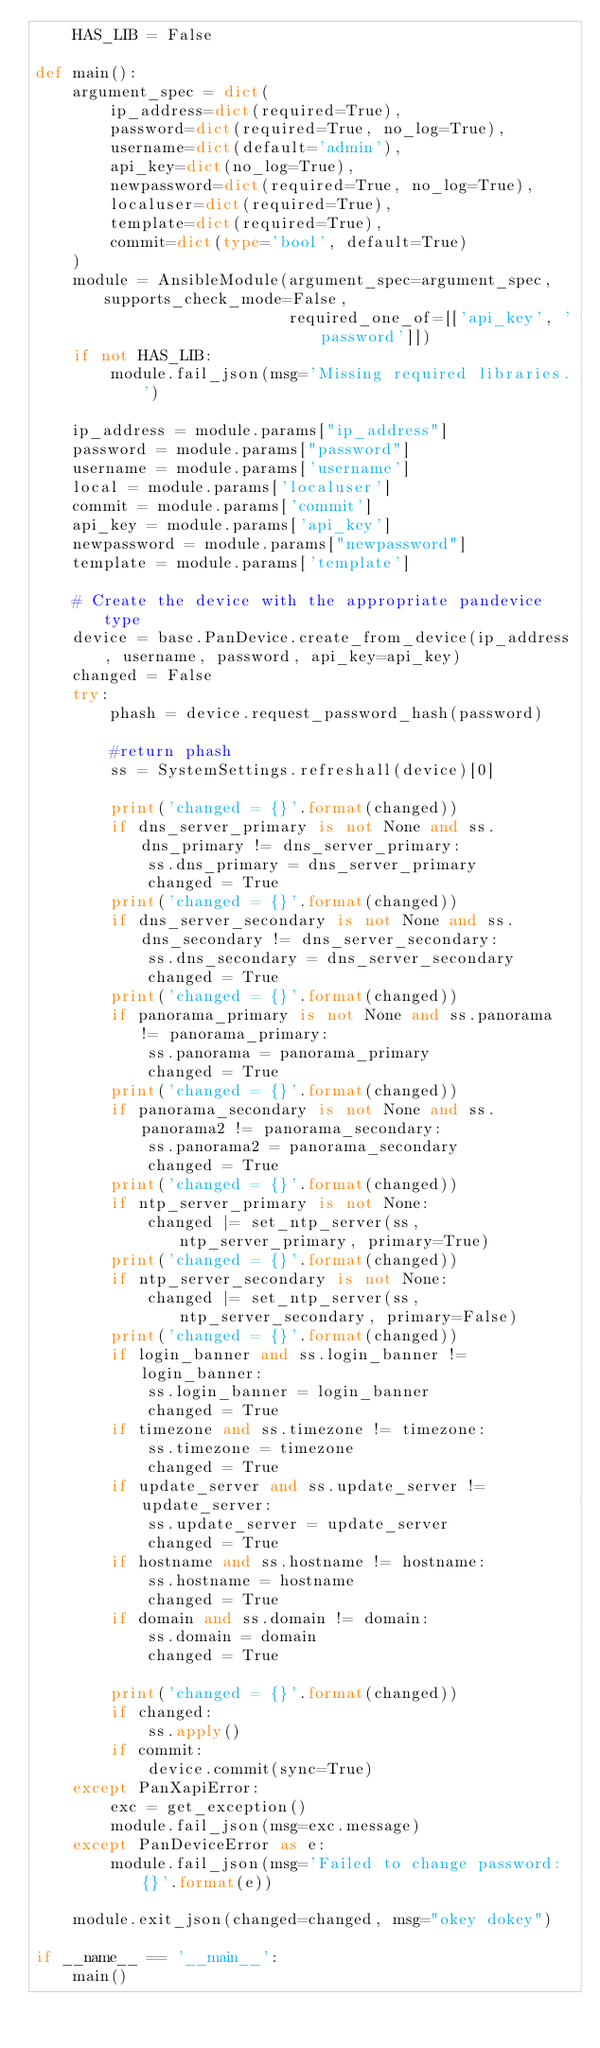<code> <loc_0><loc_0><loc_500><loc_500><_Python_>    HAS_LIB = False

def main():
    argument_spec = dict(
        ip_address=dict(required=True),
        password=dict(required=True, no_log=True),
        username=dict(default='admin'),
        api_key=dict(no_log=True),
        newpassword=dict(required=True, no_log=True),
        localuser=dict(required=True),
        template=dict(required=True),
        commit=dict(type='bool', default=True)
    )
    module = AnsibleModule(argument_spec=argument_spec, supports_check_mode=False,
                           required_one_of=[['api_key', 'password']])
    if not HAS_LIB:
        module.fail_json(msg='Missing required libraries.')

    ip_address = module.params["ip_address"]
    password = module.params["password"]
    username = module.params['username']
    local = module.params['localuser']
    commit = module.params['commit']
    api_key = module.params['api_key']
    newpassword = module.params["newpassword"]    
    template = module.params['template']

    # Create the device with the appropriate pandevice type
    device = base.PanDevice.create_from_device(ip_address, username, password, api_key=api_key)
    changed = False
    try:
        phash = device.request_password_hash(password)

        #return phash        
        ss = SystemSettings.refreshall(device)[0]

        print('changed = {}'.format(changed))
        if dns_server_primary is not None and ss.dns_primary != dns_server_primary:
            ss.dns_primary = dns_server_primary
            changed = True
        print('changed = {}'.format(changed))
        if dns_server_secondary is not None and ss.dns_secondary != dns_server_secondary:
            ss.dns_secondary = dns_server_secondary
            changed = True
        print('changed = {}'.format(changed))
        if panorama_primary is not None and ss.panorama != panorama_primary:
            ss.panorama = panorama_primary
            changed = True
        print('changed = {}'.format(changed))
        if panorama_secondary is not None and ss.panorama2 != panorama_secondary:
            ss.panorama2 = panorama_secondary
            changed = True
        print('changed = {}'.format(changed))
        if ntp_server_primary is not None:
            changed |= set_ntp_server(ss, ntp_server_primary, primary=True)
        print('changed = {}'.format(changed))
        if ntp_server_secondary is not None:
            changed |= set_ntp_server(ss, ntp_server_secondary, primary=False)
        print('changed = {}'.format(changed))
        if login_banner and ss.login_banner != login_banner:
            ss.login_banner = login_banner
            changed = True
        if timezone and ss.timezone != timezone:
            ss.timezone = timezone
            changed = True
        if update_server and ss.update_server != update_server:
            ss.update_server = update_server
            changed = True
        if hostname and ss.hostname != hostname:
            ss.hostname = hostname
            changed = True
        if domain and ss.domain != domain:
            ss.domain = domain
            changed = True

        print('changed = {}'.format(changed))
        if changed:
            ss.apply()
        if commit:
            device.commit(sync=True)
    except PanXapiError:
        exc = get_exception()
        module.fail_json(msg=exc.message)
    except PanDeviceError as e:
        module.fail_json(msg='Failed to change password: {}'.format(e))

    module.exit_json(changed=changed, msg="okey dokey")

if __name__ == '__main__':
    main()
</code> 